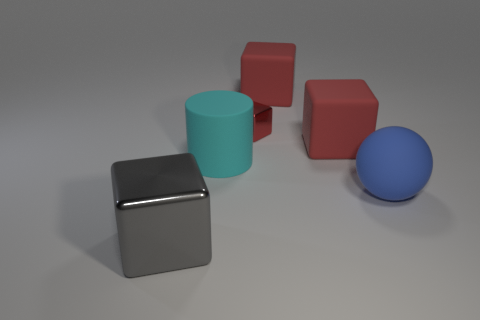What number of things are either things that are behind the blue object or blocks left of the small metallic object?
Your response must be concise. 5. Is the gray thing made of the same material as the small thing that is to the right of the big cylinder?
Provide a succinct answer. Yes. The object that is both in front of the large cylinder and on the left side of the tiny red shiny object has what shape?
Provide a succinct answer. Cube. How many other things are the same color as the big rubber cylinder?
Give a very brief answer. 0. What shape is the gray metallic object?
Your response must be concise. Cube. There is a shiny thing on the right side of the object in front of the large blue rubber ball; what color is it?
Your answer should be very brief. Red. Do the large matte cylinder and the large object in front of the large rubber sphere have the same color?
Offer a very short reply. No. What material is the big object that is both in front of the big cyan matte object and on the right side of the large cyan cylinder?
Offer a very short reply. Rubber. Is there another shiny object that has the same size as the gray metallic object?
Provide a short and direct response. No. What material is the cyan cylinder that is the same size as the gray thing?
Your answer should be very brief. Rubber. 